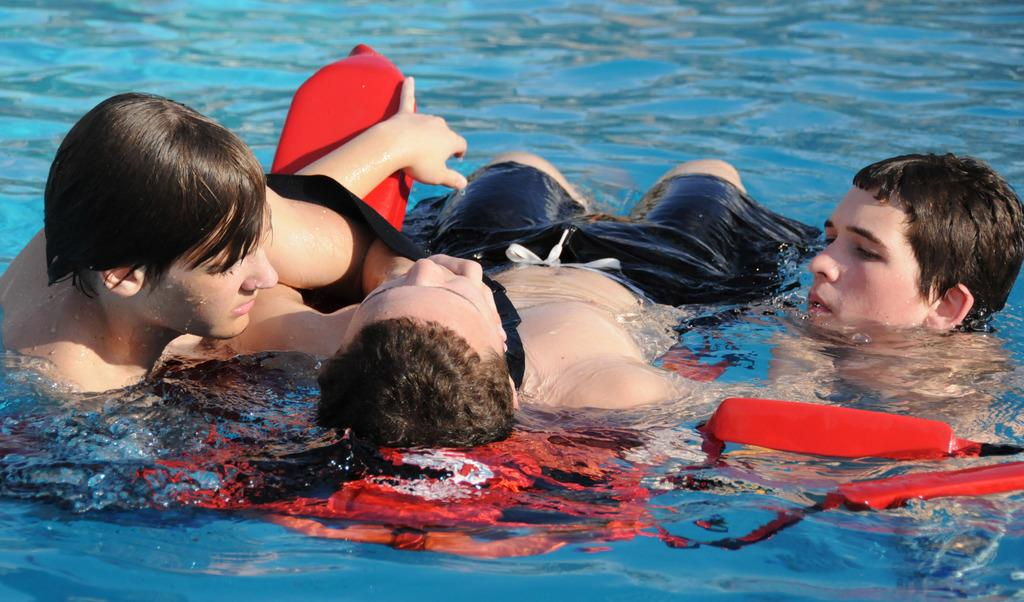How many people are in the image? There are three men in the image. What is the setting of the image? The men are on a water body. What is one of the men doing in the image? One of the men is sitting on a floating chair. What type of chalk is being used by the men in the image? There is no chalk present in the image. How many islands can be seen in the image? There are no islands visible in the image; it features a water body with three men. 